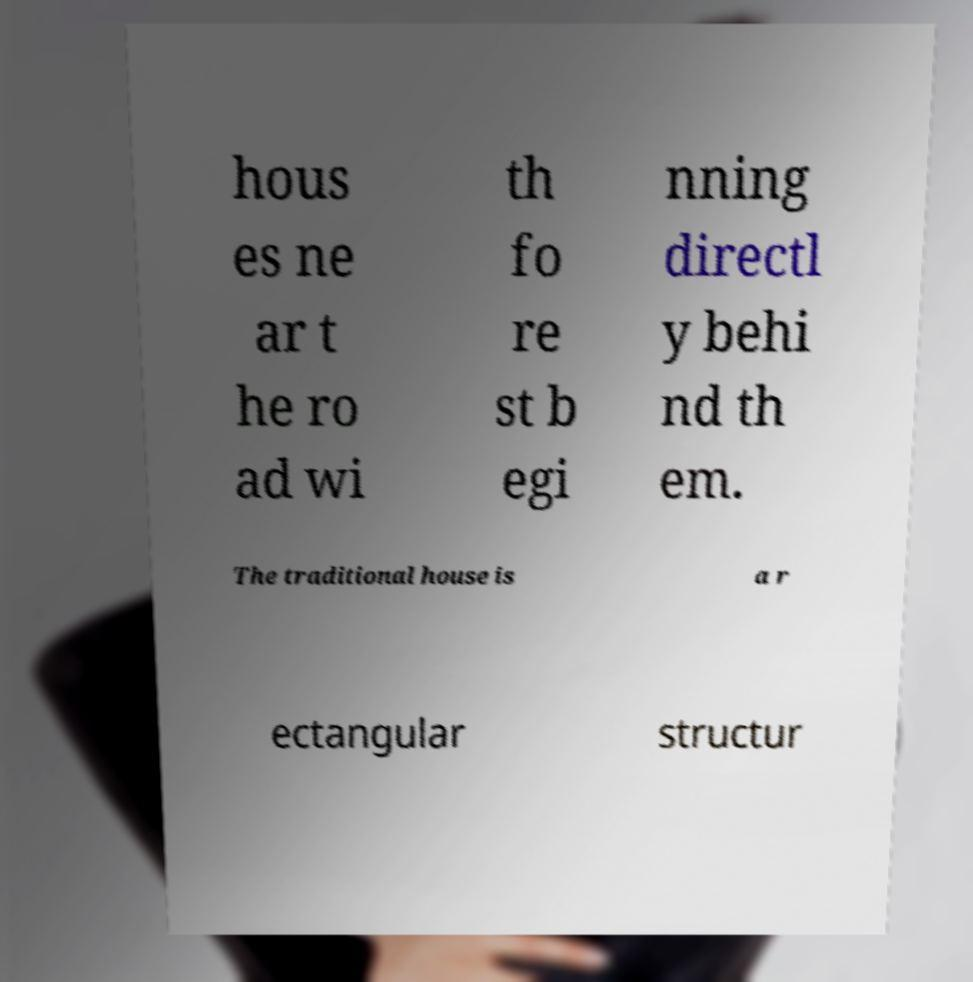Can you read and provide the text displayed in the image?This photo seems to have some interesting text. Can you extract and type it out for me? hous es ne ar t he ro ad wi th fo re st b egi nning directl y behi nd th em. The traditional house is a r ectangular structur 